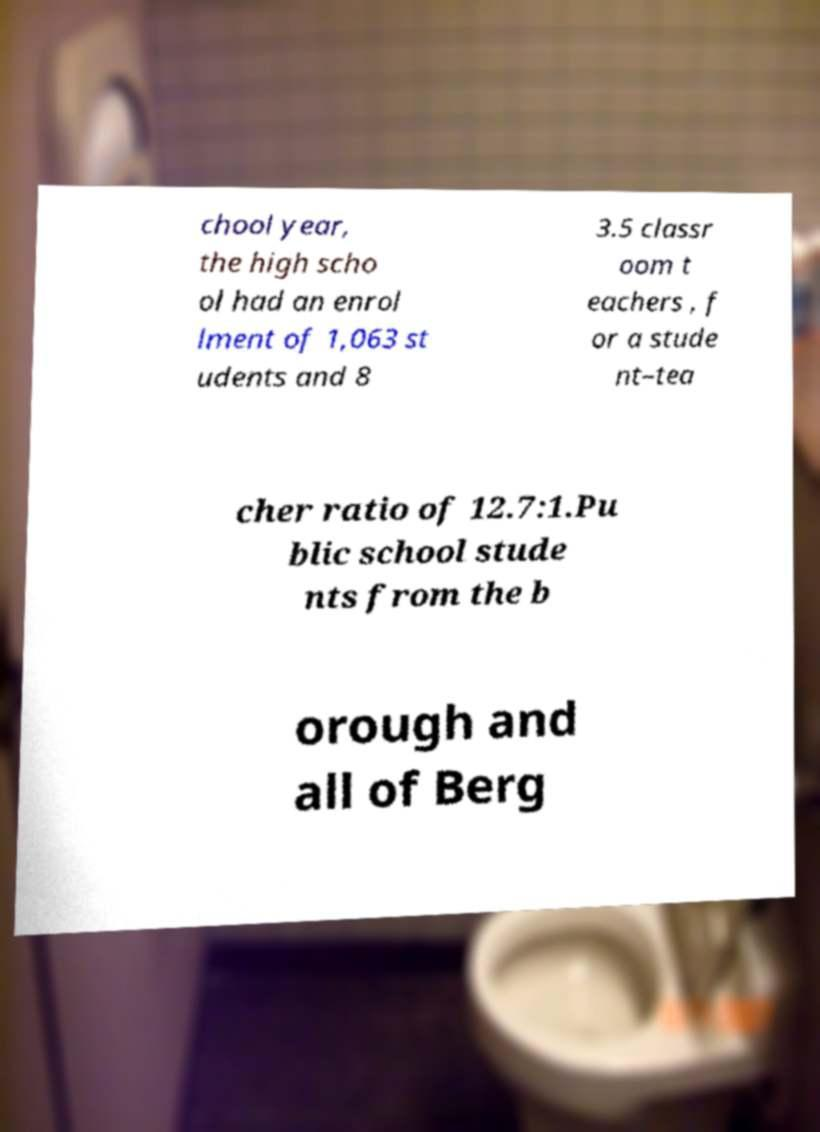Can you accurately transcribe the text from the provided image for me? chool year, the high scho ol had an enrol lment of 1,063 st udents and 8 3.5 classr oom t eachers , f or a stude nt–tea cher ratio of 12.7:1.Pu blic school stude nts from the b orough and all of Berg 